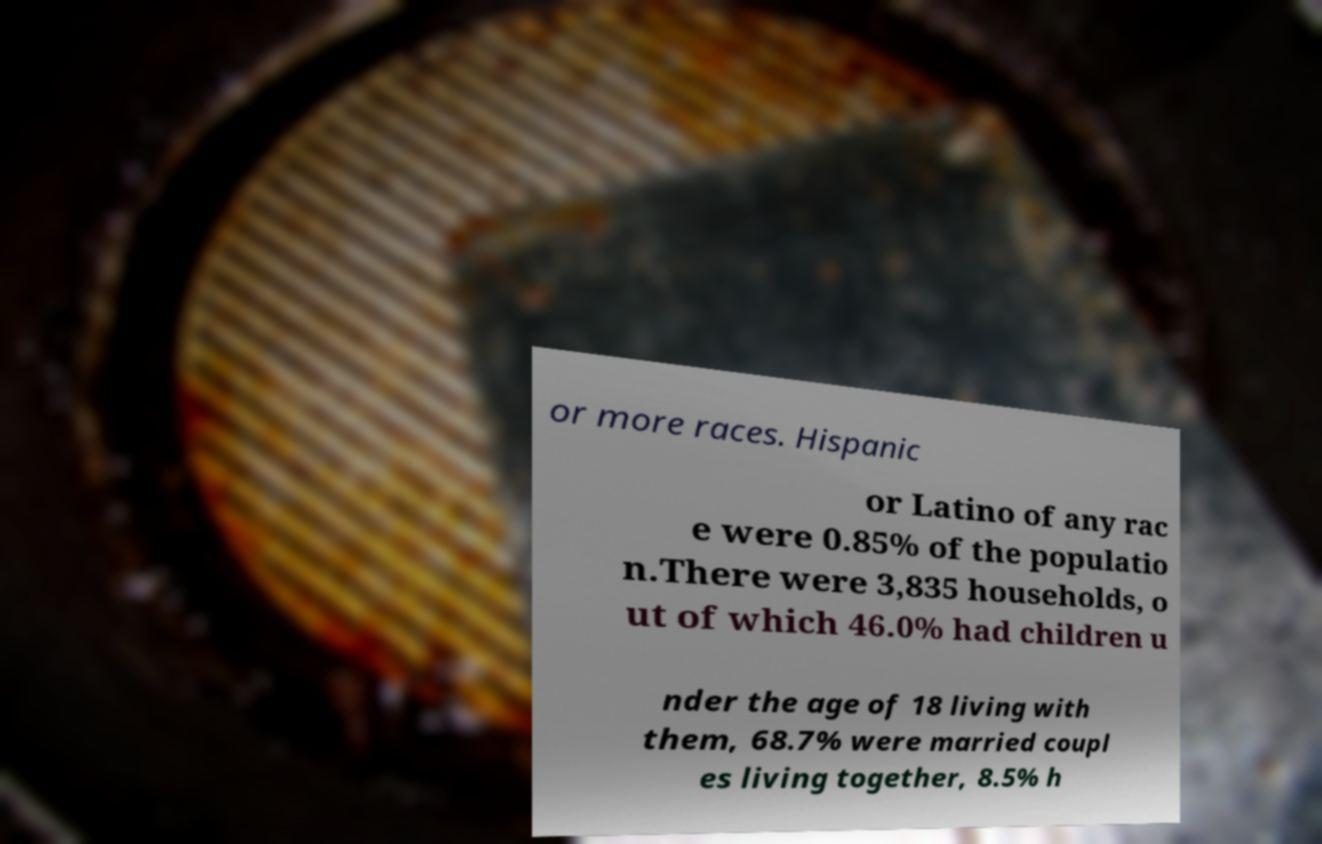Can you accurately transcribe the text from the provided image for me? or more races. Hispanic or Latino of any rac e were 0.85% of the populatio n.There were 3,835 households, o ut of which 46.0% had children u nder the age of 18 living with them, 68.7% were married coupl es living together, 8.5% h 